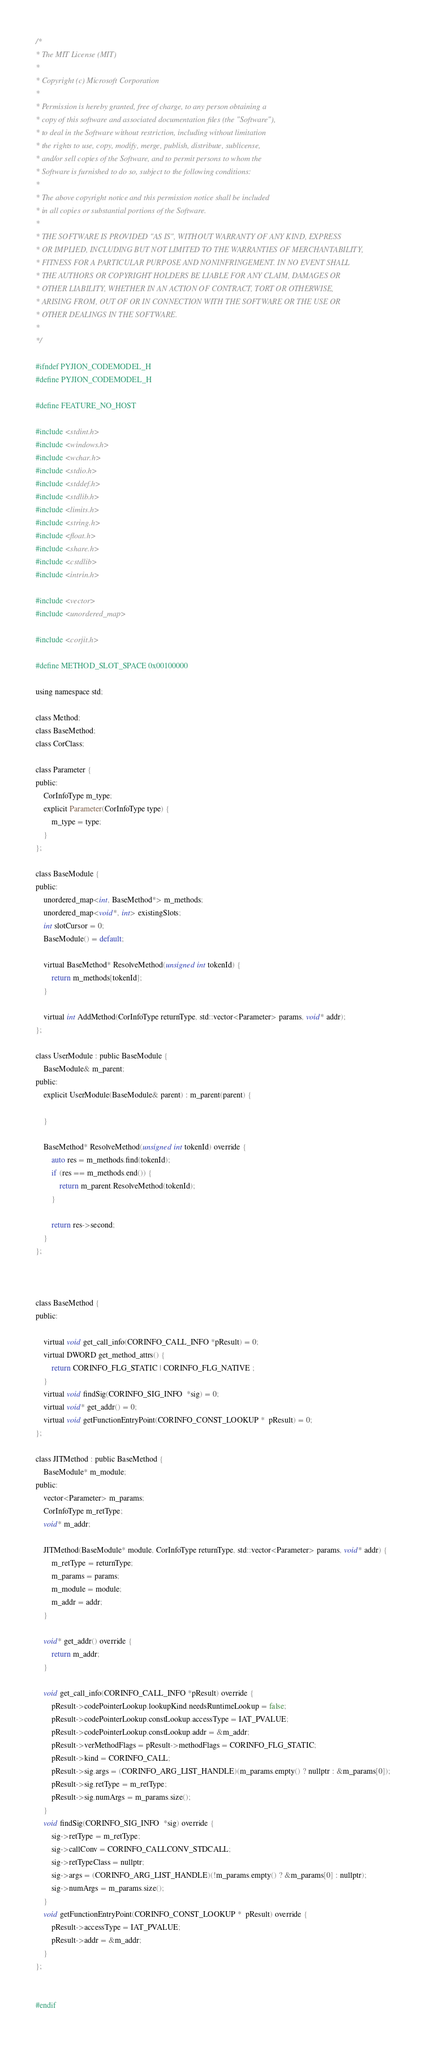Convert code to text. <code><loc_0><loc_0><loc_500><loc_500><_C_>/*
* The MIT License (MIT)
*
* Copyright (c) Microsoft Corporation
*
* Permission is hereby granted, free of charge, to any person obtaining a
* copy of this software and associated documentation files (the "Software"),
* to deal in the Software without restriction, including without limitation
* the rights to use, copy, modify, merge, publish, distribute, sublicense,
* and/or sell copies of the Software, and to permit persons to whom the
* Software is furnished to do so, subject to the following conditions:
*
* The above copyright notice and this permission notice shall be included
* in all copies or substantial portions of the Software.
*
* THE SOFTWARE IS PROVIDED "AS IS", WITHOUT WARRANTY OF ANY KIND, EXPRESS
* OR IMPLIED, INCLUDING BUT NOT LIMITED TO THE WARRANTIES OF MERCHANTABILITY,
* FITNESS FOR A PARTICULAR PURPOSE AND NONINFRINGEMENT. IN NO EVENT SHALL
* THE AUTHORS OR COPYRIGHT HOLDERS BE LIABLE FOR ANY CLAIM, DAMAGES OR
* OTHER LIABILITY, WHETHER IN AN ACTION OF CONTRACT, TORT OR OTHERWISE,
* ARISING FROM, OUT OF OR IN CONNECTION WITH THE SOFTWARE OR THE USE OR
* OTHER DEALINGS IN THE SOFTWARE.
*
*/

#ifndef PYJION_CODEMODEL_H
#define PYJION_CODEMODEL_H

#define FEATURE_NO_HOST

#include <stdint.h>
#include <windows.h>
#include <wchar.h>
#include <stdio.h>
#include <stddef.h>
#include <stdlib.h>
#include <limits.h>
#include <string.h>
#include <float.h>
#include <share.h>
#include <cstdlib>
#include <intrin.h>

#include <vector>
#include <unordered_map>

#include <corjit.h>

#define METHOD_SLOT_SPACE 0x00100000

using namespace std;

class Method;
class BaseMethod;
class CorClass;

class Parameter {
public:
    CorInfoType m_type;
    explicit Parameter(CorInfoType type) {
        m_type = type;
    }
};

class BaseModule {
public:
    unordered_map<int, BaseMethod*> m_methods;
    unordered_map<void*, int> existingSlots;
    int slotCursor = 0;
    BaseModule() = default;

    virtual BaseMethod* ResolveMethod(unsigned int tokenId) {
        return m_methods[tokenId];
    }

    virtual int AddMethod(CorInfoType returnType, std::vector<Parameter> params, void* addr);
};

class UserModule : public BaseModule {
    BaseModule& m_parent;
public:
    explicit UserModule(BaseModule& parent) : m_parent(parent) {

    }

    BaseMethod* ResolveMethod(unsigned int tokenId) override {
        auto res = m_methods.find(tokenId);
        if (res == m_methods.end()) {
            return m_parent.ResolveMethod(tokenId);
        }

        return res->second;
    }
};



class BaseMethod {
public:

    virtual void get_call_info(CORINFO_CALL_INFO *pResult) = 0;
    virtual DWORD get_method_attrs() {
        return CORINFO_FLG_STATIC | CORINFO_FLG_NATIVE ;
    }
    virtual void findSig(CORINFO_SIG_INFO  *sig) = 0;
    virtual void* get_addr() = 0;
    virtual void getFunctionEntryPoint(CORINFO_CONST_LOOKUP *  pResult) = 0;
};

class JITMethod : public BaseMethod {
    BaseModule* m_module;
public:
    vector<Parameter> m_params;
    CorInfoType m_retType;
    void* m_addr;

    JITMethod(BaseModule* module, CorInfoType returnType, std::vector<Parameter> params, void* addr) {
        m_retType = returnType;
        m_params = params;
        m_module = module;
        m_addr = addr;
    }

    void* get_addr() override {
        return m_addr;
    }

    void get_call_info(CORINFO_CALL_INFO *pResult) override {
        pResult->codePointerLookup.lookupKind.needsRuntimeLookup = false;
        pResult->codePointerLookup.constLookup.accessType = IAT_PVALUE;
        pResult->codePointerLookup.constLookup.addr = &m_addr;
        pResult->verMethodFlags = pResult->methodFlags = CORINFO_FLG_STATIC;
        pResult->kind = CORINFO_CALL;
        pResult->sig.args = (CORINFO_ARG_LIST_HANDLE)(m_params.empty() ? nullptr : &m_params[0]);
        pResult->sig.retType = m_retType;
        pResult->sig.numArgs = m_params.size();
    }
    void findSig(CORINFO_SIG_INFO  *sig) override {
        sig->retType = m_retType;
        sig->callConv = CORINFO_CALLCONV_STDCALL;
        sig->retTypeClass = nullptr;
        sig->args = (CORINFO_ARG_LIST_HANDLE)(!m_params.empty() ? &m_params[0] : nullptr);
        sig->numArgs = m_params.size();
    }
    void getFunctionEntryPoint(CORINFO_CONST_LOOKUP *  pResult) override {
        pResult->accessType = IAT_PVALUE;
        pResult->addr = &m_addr;
    }
};


#endif</code> 